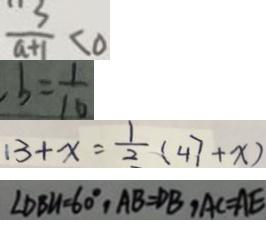Convert formula to latex. <formula><loc_0><loc_0><loc_500><loc_500>\frac { 3 } { a + 1 } < 0 
 , b = \frac { 1 } { 1 0 } 
 1 3 + x = \frac { 1 } { 2 } ( 4 7 + x ) 
 \angle D B N = 6 0 ^ { \circ } , A B = D B , A C = A E</formula> 